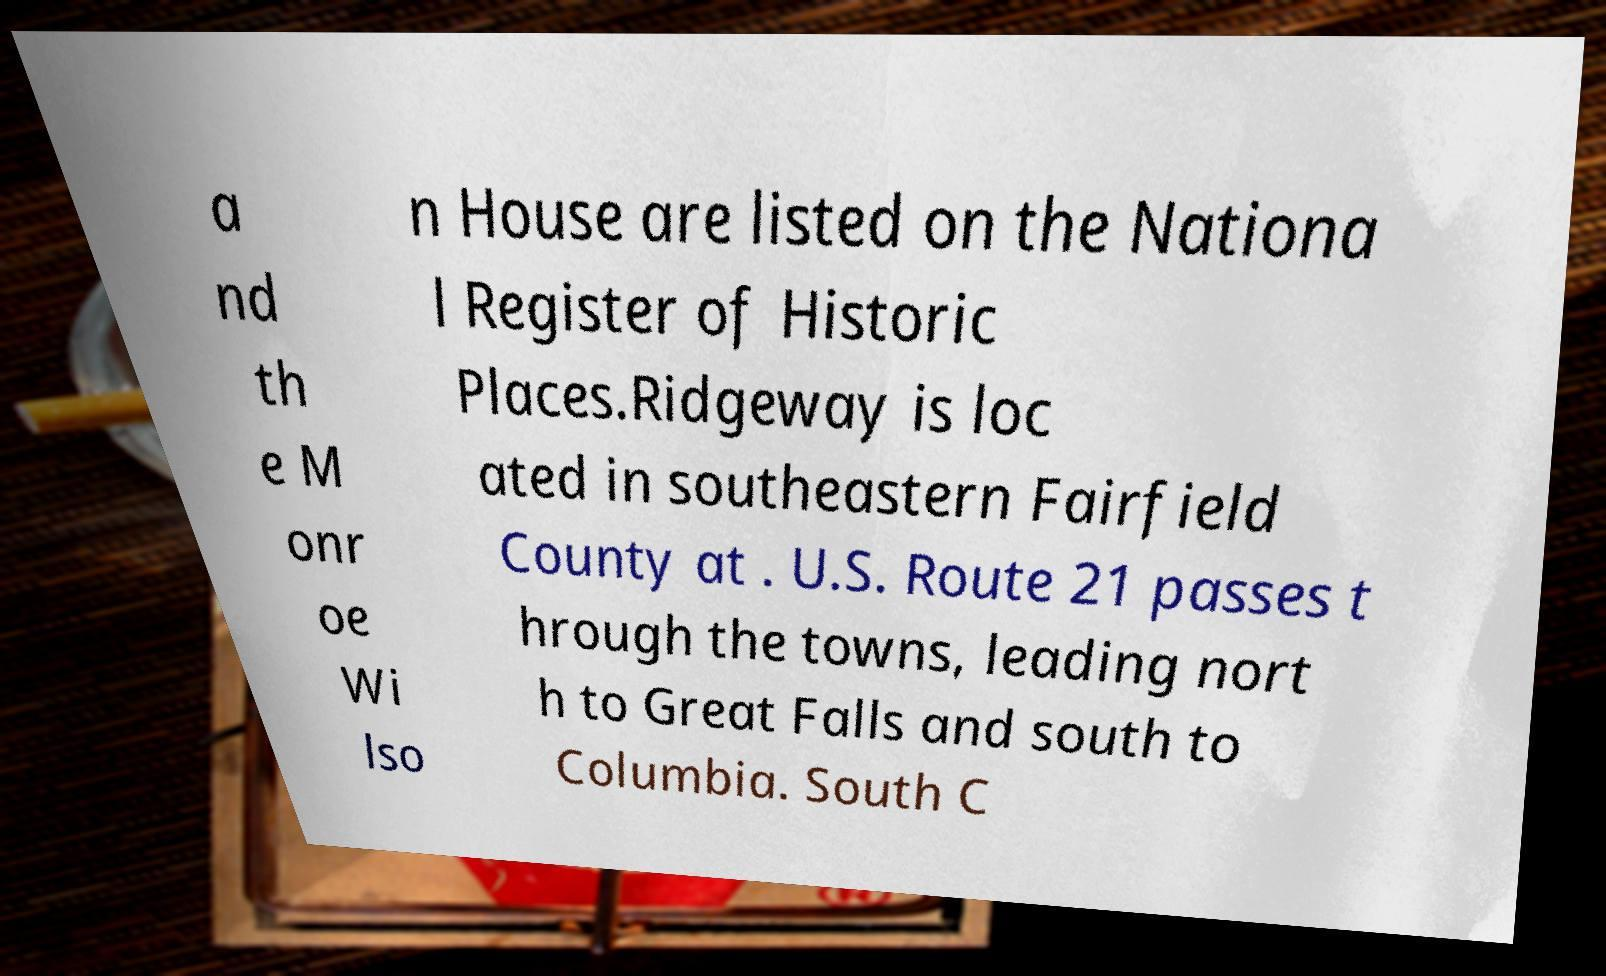For documentation purposes, I need the text within this image transcribed. Could you provide that? a nd th e M onr oe Wi lso n House are listed on the Nationa l Register of Historic Places.Ridgeway is loc ated in southeastern Fairfield County at . U.S. Route 21 passes t hrough the towns, leading nort h to Great Falls and south to Columbia. South C 